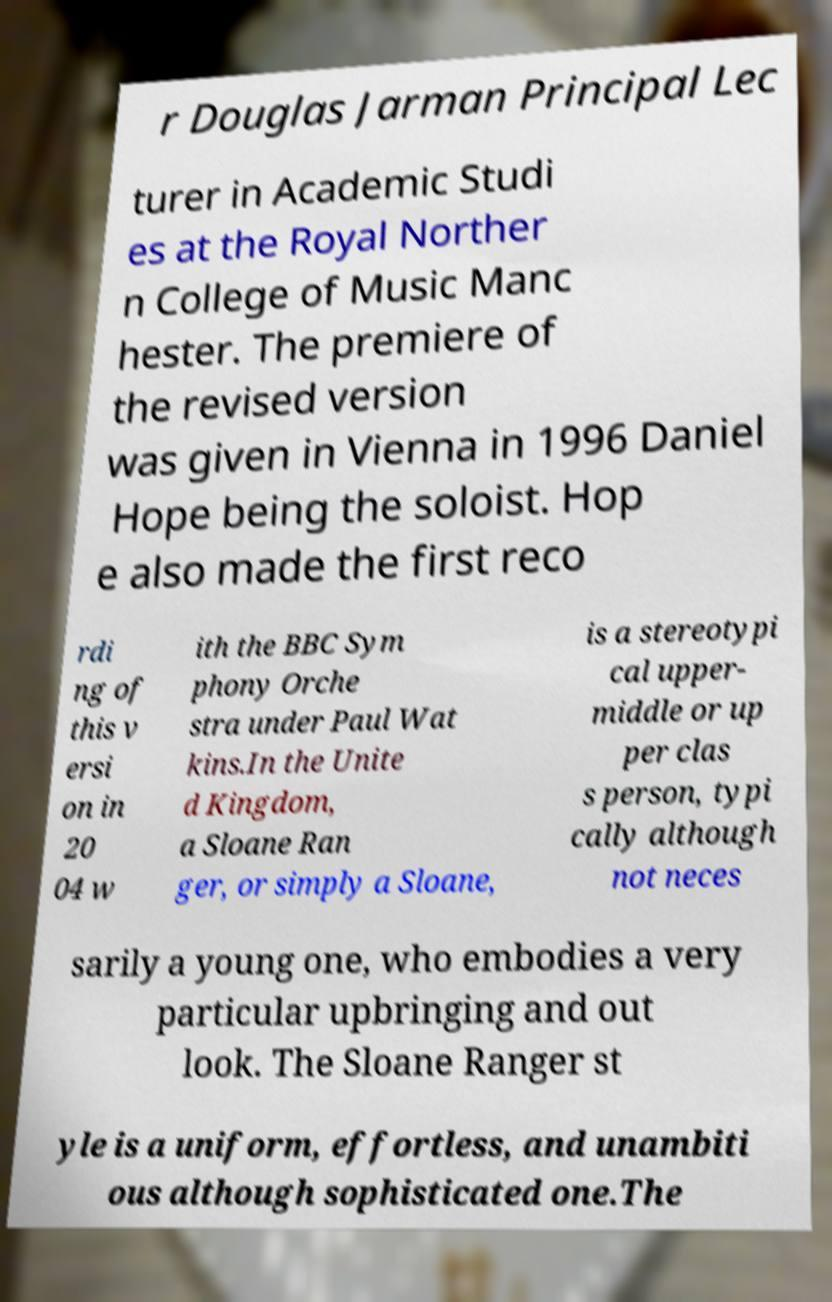Could you extract and type out the text from this image? r Douglas Jarman Principal Lec turer in Academic Studi es at the Royal Norther n College of Music Manc hester. The premiere of the revised version was given in Vienna in 1996 Daniel Hope being the soloist. Hop e also made the first reco rdi ng of this v ersi on in 20 04 w ith the BBC Sym phony Orche stra under Paul Wat kins.In the Unite d Kingdom, a Sloane Ran ger, or simply a Sloane, is a stereotypi cal upper- middle or up per clas s person, typi cally although not neces sarily a young one, who embodies a very particular upbringing and out look. The Sloane Ranger st yle is a uniform, effortless, and unambiti ous although sophisticated one.The 